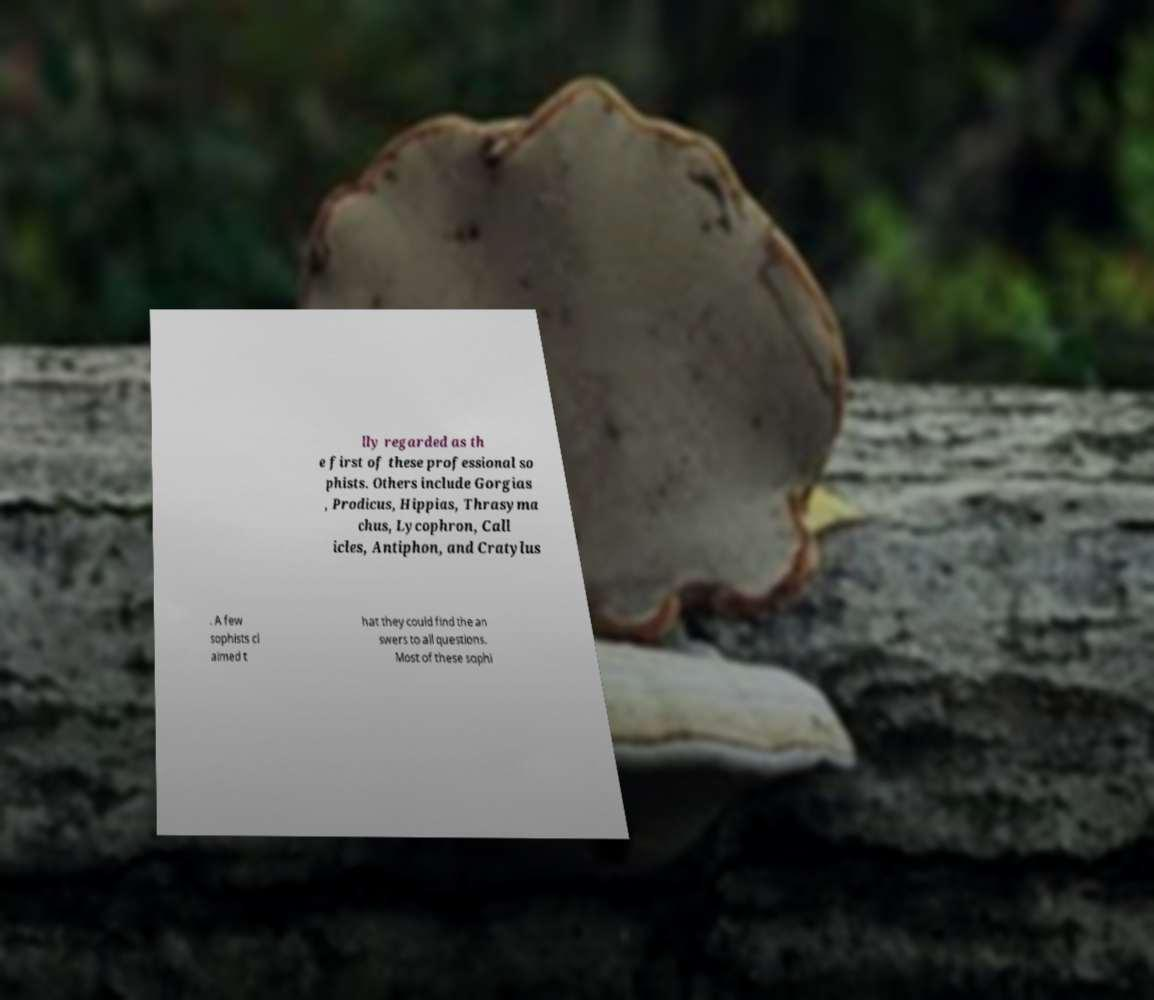Can you read and provide the text displayed in the image?This photo seems to have some interesting text. Can you extract and type it out for me? lly regarded as th e first of these professional so phists. Others include Gorgias , Prodicus, Hippias, Thrasyma chus, Lycophron, Call icles, Antiphon, and Cratylus . A few sophists cl aimed t hat they could find the an swers to all questions. Most of these sophi 